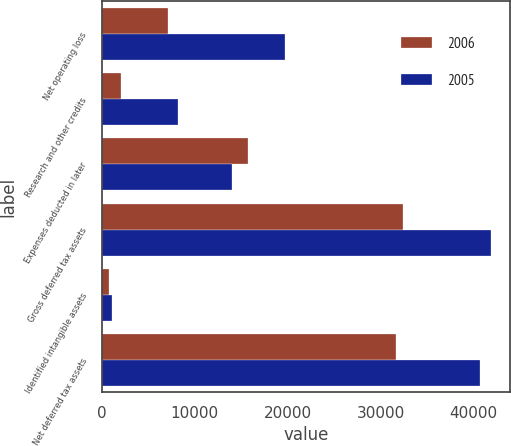Convert chart to OTSL. <chart><loc_0><loc_0><loc_500><loc_500><stacked_bar_chart><ecel><fcel>Net operating loss<fcel>Research and other credits<fcel>Expenses deducted in later<fcel>Gross deferred tax assets<fcel>Identified intangible assets<fcel>Net deferred tax assets<nl><fcel>2006<fcel>7066<fcel>1994<fcel>15735<fcel>32471<fcel>794<fcel>31677<nl><fcel>2005<fcel>19710<fcel>8148<fcel>14006<fcel>41864<fcel>1106<fcel>40758<nl></chart> 